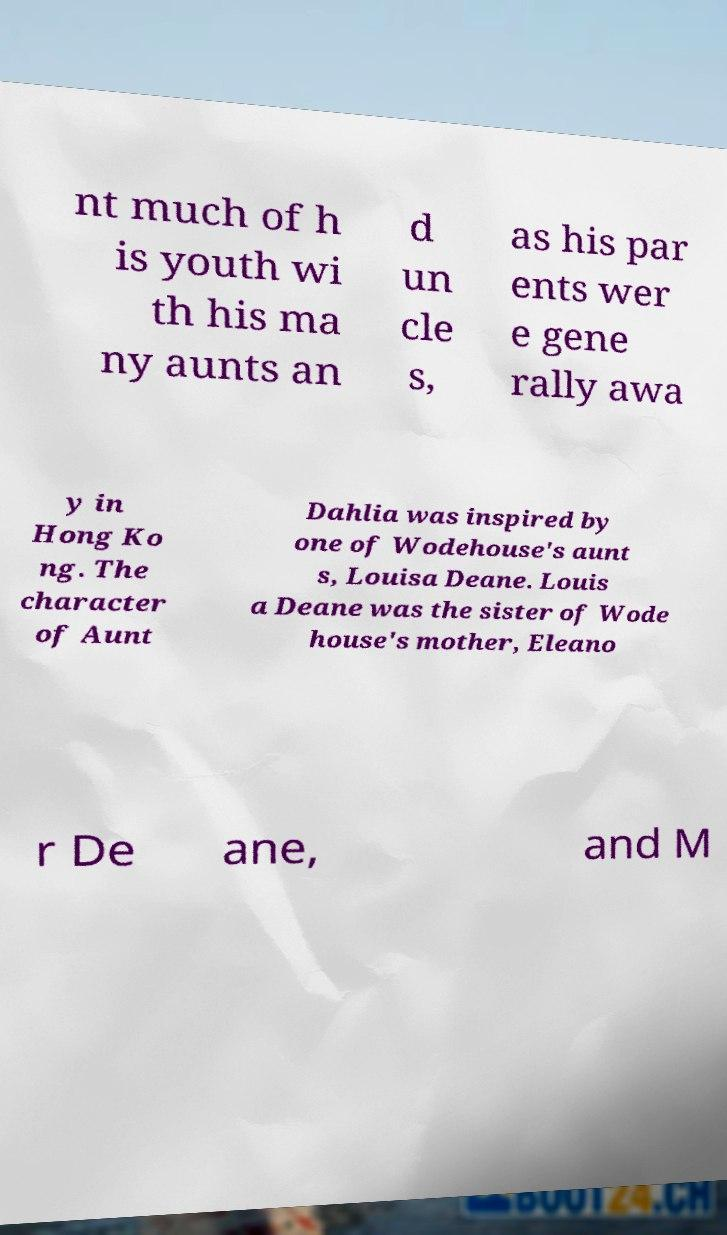Can you read and provide the text displayed in the image?This photo seems to have some interesting text. Can you extract and type it out for me? nt much of h is youth wi th his ma ny aunts an d un cle s, as his par ents wer e gene rally awa y in Hong Ko ng. The character of Aunt Dahlia was inspired by one of Wodehouse's aunt s, Louisa Deane. Louis a Deane was the sister of Wode house's mother, Eleano r De ane, and M 